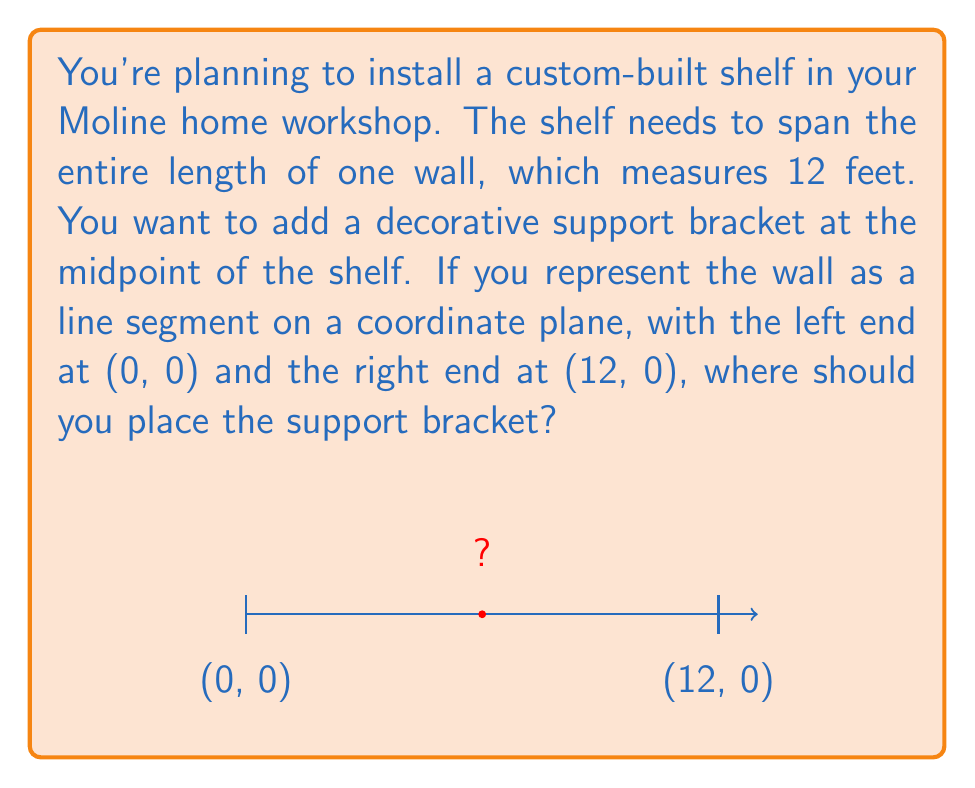Can you answer this question? To find the midpoint of the line segment, we can use the midpoint formula:

$$ \text{Midpoint} = \left(\frac{x_1 + x_2}{2}, \frac{y_1 + y_2}{2}\right) $$

Where $(x_1, y_1)$ is the coordinate of one endpoint and $(x_2, y_2)$ is the coordinate of the other endpoint.

In this case:
$(x_1, y_1) = (0, 0)$ (left end of the wall)
$(x_2, y_2) = (12, 0)$ (right end of the wall)

Let's calculate:

1) For the x-coordinate:
   $$ \frac{x_1 + x_2}{2} = \frac{0 + 12}{2} = \frac{12}{2} = 6 $$

2) For the y-coordinate:
   $$ \frac{y_1 + y_2}{2} = \frac{0 + 0}{2} = 0 $$

Therefore, the midpoint is at (6, 0).

This means you should place the support bracket 6 feet from either end of the wall.
Answer: (6, 0) 